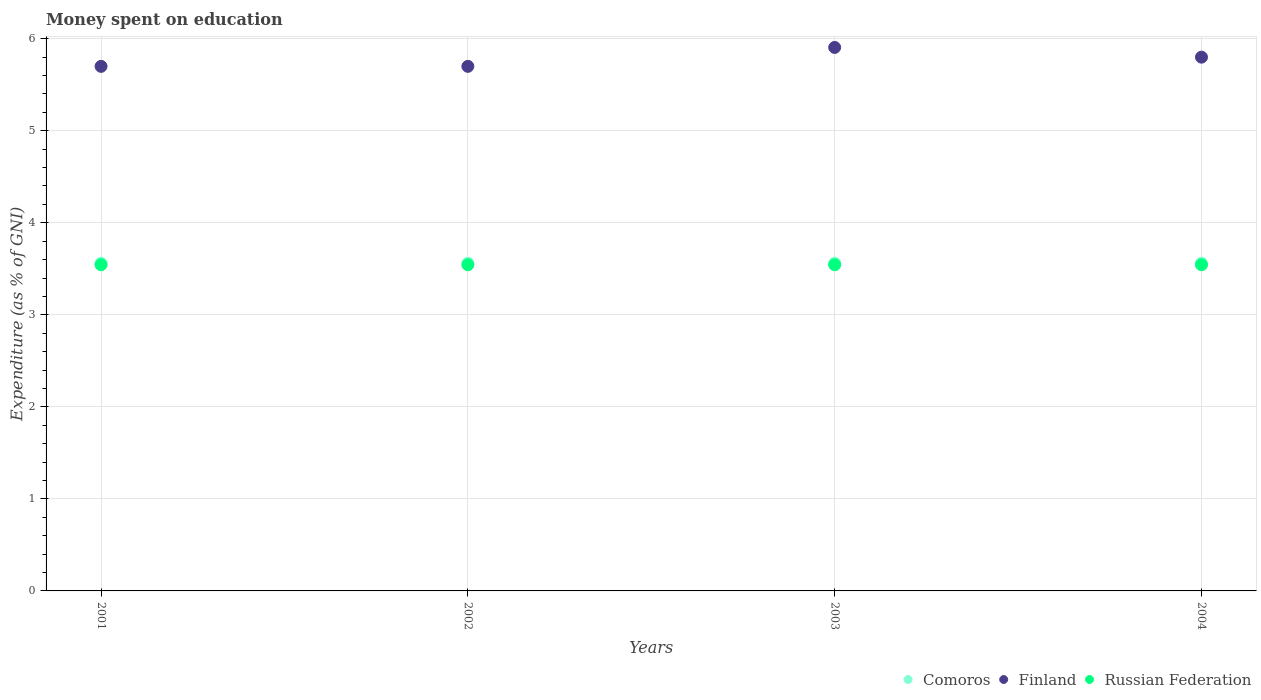How many different coloured dotlines are there?
Offer a terse response. 3. Is the number of dotlines equal to the number of legend labels?
Your response must be concise. Yes. What is the amount of money spent on education in Finland in 2001?
Provide a short and direct response. 5.7. Across all years, what is the maximum amount of money spent on education in Comoros?
Offer a terse response. 3.56. Across all years, what is the minimum amount of money spent on education in Finland?
Provide a short and direct response. 5.7. What is the total amount of money spent on education in Russian Federation in the graph?
Ensure brevity in your answer.  14.18. What is the difference between the amount of money spent on education in Comoros in 2003 and the amount of money spent on education in Russian Federation in 2001?
Provide a short and direct response. 0.02. What is the average amount of money spent on education in Finland per year?
Ensure brevity in your answer.  5.78. In the year 2003, what is the difference between the amount of money spent on education in Finland and amount of money spent on education in Russian Federation?
Offer a very short reply. 2.36. What is the ratio of the amount of money spent on education in Russian Federation in 2001 to that in 2002?
Make the answer very short. 1. Is the difference between the amount of money spent on education in Finland in 2001 and 2004 greater than the difference between the amount of money spent on education in Russian Federation in 2001 and 2004?
Offer a terse response. No. What is the difference between the highest and the second highest amount of money spent on education in Finland?
Offer a very short reply. 0.11. What is the difference between the highest and the lowest amount of money spent on education in Finland?
Give a very brief answer. 0.21. Is it the case that in every year, the sum of the amount of money spent on education in Finland and amount of money spent on education in Russian Federation  is greater than the amount of money spent on education in Comoros?
Provide a succinct answer. Yes. Is the amount of money spent on education in Russian Federation strictly greater than the amount of money spent on education in Comoros over the years?
Ensure brevity in your answer.  No. How many dotlines are there?
Provide a short and direct response. 3. How many years are there in the graph?
Provide a succinct answer. 4. What is the difference between two consecutive major ticks on the Y-axis?
Give a very brief answer. 1. Does the graph contain grids?
Provide a succinct answer. Yes. How many legend labels are there?
Provide a succinct answer. 3. What is the title of the graph?
Your answer should be compact. Money spent on education. What is the label or title of the X-axis?
Provide a succinct answer. Years. What is the label or title of the Y-axis?
Make the answer very short. Expenditure (as % of GNI). What is the Expenditure (as % of GNI) in Comoros in 2001?
Ensure brevity in your answer.  3.56. What is the Expenditure (as % of GNI) in Russian Federation in 2001?
Offer a very short reply. 3.54. What is the Expenditure (as % of GNI) of Comoros in 2002?
Provide a short and direct response. 3.56. What is the Expenditure (as % of GNI) of Russian Federation in 2002?
Ensure brevity in your answer.  3.54. What is the Expenditure (as % of GNI) of Comoros in 2003?
Give a very brief answer. 3.56. What is the Expenditure (as % of GNI) in Finland in 2003?
Make the answer very short. 5.91. What is the Expenditure (as % of GNI) in Russian Federation in 2003?
Make the answer very short. 3.54. What is the Expenditure (as % of GNI) in Comoros in 2004?
Your response must be concise. 3.56. What is the Expenditure (as % of GNI) of Russian Federation in 2004?
Your answer should be compact. 3.54. Across all years, what is the maximum Expenditure (as % of GNI) of Comoros?
Offer a very short reply. 3.56. Across all years, what is the maximum Expenditure (as % of GNI) of Finland?
Provide a short and direct response. 5.91. Across all years, what is the maximum Expenditure (as % of GNI) in Russian Federation?
Offer a very short reply. 3.54. Across all years, what is the minimum Expenditure (as % of GNI) in Comoros?
Offer a terse response. 3.56. Across all years, what is the minimum Expenditure (as % of GNI) of Finland?
Offer a very short reply. 5.7. Across all years, what is the minimum Expenditure (as % of GNI) in Russian Federation?
Ensure brevity in your answer.  3.54. What is the total Expenditure (as % of GNI) of Comoros in the graph?
Your response must be concise. 14.25. What is the total Expenditure (as % of GNI) of Finland in the graph?
Provide a succinct answer. 23.11. What is the total Expenditure (as % of GNI) in Russian Federation in the graph?
Keep it short and to the point. 14.18. What is the difference between the Expenditure (as % of GNI) in Russian Federation in 2001 and that in 2002?
Your answer should be compact. 0. What is the difference between the Expenditure (as % of GNI) in Comoros in 2001 and that in 2003?
Keep it short and to the point. 0. What is the difference between the Expenditure (as % of GNI) of Finland in 2001 and that in 2003?
Offer a very short reply. -0.21. What is the difference between the Expenditure (as % of GNI) in Finland in 2002 and that in 2003?
Give a very brief answer. -0.21. What is the difference between the Expenditure (as % of GNI) in Russian Federation in 2002 and that in 2003?
Provide a short and direct response. 0. What is the difference between the Expenditure (as % of GNI) of Comoros in 2002 and that in 2004?
Keep it short and to the point. 0. What is the difference between the Expenditure (as % of GNI) in Finland in 2002 and that in 2004?
Give a very brief answer. -0.1. What is the difference between the Expenditure (as % of GNI) in Russian Federation in 2002 and that in 2004?
Offer a very short reply. 0. What is the difference between the Expenditure (as % of GNI) of Finland in 2003 and that in 2004?
Your response must be concise. 0.11. What is the difference between the Expenditure (as % of GNI) of Russian Federation in 2003 and that in 2004?
Offer a very short reply. 0. What is the difference between the Expenditure (as % of GNI) in Comoros in 2001 and the Expenditure (as % of GNI) in Finland in 2002?
Provide a short and direct response. -2.14. What is the difference between the Expenditure (as % of GNI) of Comoros in 2001 and the Expenditure (as % of GNI) of Russian Federation in 2002?
Offer a terse response. 0.02. What is the difference between the Expenditure (as % of GNI) in Finland in 2001 and the Expenditure (as % of GNI) in Russian Federation in 2002?
Provide a short and direct response. 2.16. What is the difference between the Expenditure (as % of GNI) of Comoros in 2001 and the Expenditure (as % of GNI) of Finland in 2003?
Offer a terse response. -2.34. What is the difference between the Expenditure (as % of GNI) in Comoros in 2001 and the Expenditure (as % of GNI) in Russian Federation in 2003?
Provide a succinct answer. 0.02. What is the difference between the Expenditure (as % of GNI) of Finland in 2001 and the Expenditure (as % of GNI) of Russian Federation in 2003?
Provide a short and direct response. 2.16. What is the difference between the Expenditure (as % of GNI) of Comoros in 2001 and the Expenditure (as % of GNI) of Finland in 2004?
Provide a short and direct response. -2.24. What is the difference between the Expenditure (as % of GNI) of Comoros in 2001 and the Expenditure (as % of GNI) of Russian Federation in 2004?
Your answer should be compact. 0.02. What is the difference between the Expenditure (as % of GNI) of Finland in 2001 and the Expenditure (as % of GNI) of Russian Federation in 2004?
Offer a very short reply. 2.16. What is the difference between the Expenditure (as % of GNI) in Comoros in 2002 and the Expenditure (as % of GNI) in Finland in 2003?
Keep it short and to the point. -2.34. What is the difference between the Expenditure (as % of GNI) in Comoros in 2002 and the Expenditure (as % of GNI) in Russian Federation in 2003?
Provide a short and direct response. 0.02. What is the difference between the Expenditure (as % of GNI) in Finland in 2002 and the Expenditure (as % of GNI) in Russian Federation in 2003?
Your response must be concise. 2.16. What is the difference between the Expenditure (as % of GNI) of Comoros in 2002 and the Expenditure (as % of GNI) of Finland in 2004?
Make the answer very short. -2.24. What is the difference between the Expenditure (as % of GNI) in Comoros in 2002 and the Expenditure (as % of GNI) in Russian Federation in 2004?
Your answer should be very brief. 0.02. What is the difference between the Expenditure (as % of GNI) in Finland in 2002 and the Expenditure (as % of GNI) in Russian Federation in 2004?
Keep it short and to the point. 2.16. What is the difference between the Expenditure (as % of GNI) of Comoros in 2003 and the Expenditure (as % of GNI) of Finland in 2004?
Provide a short and direct response. -2.24. What is the difference between the Expenditure (as % of GNI) in Comoros in 2003 and the Expenditure (as % of GNI) in Russian Federation in 2004?
Make the answer very short. 0.02. What is the difference between the Expenditure (as % of GNI) in Finland in 2003 and the Expenditure (as % of GNI) in Russian Federation in 2004?
Your answer should be compact. 2.36. What is the average Expenditure (as % of GNI) of Comoros per year?
Your answer should be compact. 3.56. What is the average Expenditure (as % of GNI) in Finland per year?
Your answer should be compact. 5.78. What is the average Expenditure (as % of GNI) in Russian Federation per year?
Your response must be concise. 3.54. In the year 2001, what is the difference between the Expenditure (as % of GNI) in Comoros and Expenditure (as % of GNI) in Finland?
Ensure brevity in your answer.  -2.14. In the year 2001, what is the difference between the Expenditure (as % of GNI) in Comoros and Expenditure (as % of GNI) in Russian Federation?
Give a very brief answer. 0.02. In the year 2001, what is the difference between the Expenditure (as % of GNI) in Finland and Expenditure (as % of GNI) in Russian Federation?
Provide a short and direct response. 2.16. In the year 2002, what is the difference between the Expenditure (as % of GNI) of Comoros and Expenditure (as % of GNI) of Finland?
Give a very brief answer. -2.14. In the year 2002, what is the difference between the Expenditure (as % of GNI) in Comoros and Expenditure (as % of GNI) in Russian Federation?
Your response must be concise. 0.02. In the year 2002, what is the difference between the Expenditure (as % of GNI) in Finland and Expenditure (as % of GNI) in Russian Federation?
Your answer should be very brief. 2.16. In the year 2003, what is the difference between the Expenditure (as % of GNI) in Comoros and Expenditure (as % of GNI) in Finland?
Give a very brief answer. -2.34. In the year 2003, what is the difference between the Expenditure (as % of GNI) in Comoros and Expenditure (as % of GNI) in Russian Federation?
Your response must be concise. 0.02. In the year 2003, what is the difference between the Expenditure (as % of GNI) in Finland and Expenditure (as % of GNI) in Russian Federation?
Offer a terse response. 2.36. In the year 2004, what is the difference between the Expenditure (as % of GNI) of Comoros and Expenditure (as % of GNI) of Finland?
Provide a succinct answer. -2.24. In the year 2004, what is the difference between the Expenditure (as % of GNI) of Comoros and Expenditure (as % of GNI) of Russian Federation?
Offer a terse response. 0.02. In the year 2004, what is the difference between the Expenditure (as % of GNI) of Finland and Expenditure (as % of GNI) of Russian Federation?
Your answer should be compact. 2.26. What is the ratio of the Expenditure (as % of GNI) in Comoros in 2001 to that in 2003?
Give a very brief answer. 1. What is the ratio of the Expenditure (as % of GNI) of Finland in 2001 to that in 2003?
Provide a succinct answer. 0.97. What is the ratio of the Expenditure (as % of GNI) of Russian Federation in 2001 to that in 2003?
Ensure brevity in your answer.  1. What is the ratio of the Expenditure (as % of GNI) of Finland in 2001 to that in 2004?
Offer a terse response. 0.98. What is the ratio of the Expenditure (as % of GNI) in Finland in 2002 to that in 2003?
Provide a short and direct response. 0.97. What is the ratio of the Expenditure (as % of GNI) in Finland in 2002 to that in 2004?
Provide a short and direct response. 0.98. What is the ratio of the Expenditure (as % of GNI) of Comoros in 2003 to that in 2004?
Provide a short and direct response. 1. What is the ratio of the Expenditure (as % of GNI) in Finland in 2003 to that in 2004?
Your answer should be very brief. 1.02. What is the difference between the highest and the second highest Expenditure (as % of GNI) in Comoros?
Keep it short and to the point. 0. What is the difference between the highest and the second highest Expenditure (as % of GNI) of Finland?
Give a very brief answer. 0.11. What is the difference between the highest and the second highest Expenditure (as % of GNI) in Russian Federation?
Provide a short and direct response. 0. What is the difference between the highest and the lowest Expenditure (as % of GNI) of Finland?
Offer a very short reply. 0.21. 